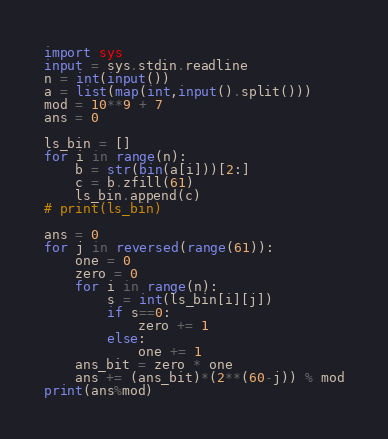Convert code to text. <code><loc_0><loc_0><loc_500><loc_500><_Python_>import sys
input = sys.stdin.readline
n = int(input())
a = list(map(int,input().split()))
mod = 10**9 + 7
ans = 0

ls_bin = []
for i in range(n):
    b = str(bin(a[i]))[2:]
    c = b.zfill(61)
    ls_bin.append(c)
# print(ls_bin)

ans = 0
for j in reversed(range(61)):
    one = 0
    zero = 0
    for i in range(n):
        s = int(ls_bin[i][j])
        if s==0:
            zero += 1
        else:
            one += 1
    ans_bit = zero * one
    ans += (ans_bit)*(2**(60-j)) % mod
print(ans%mod)</code> 